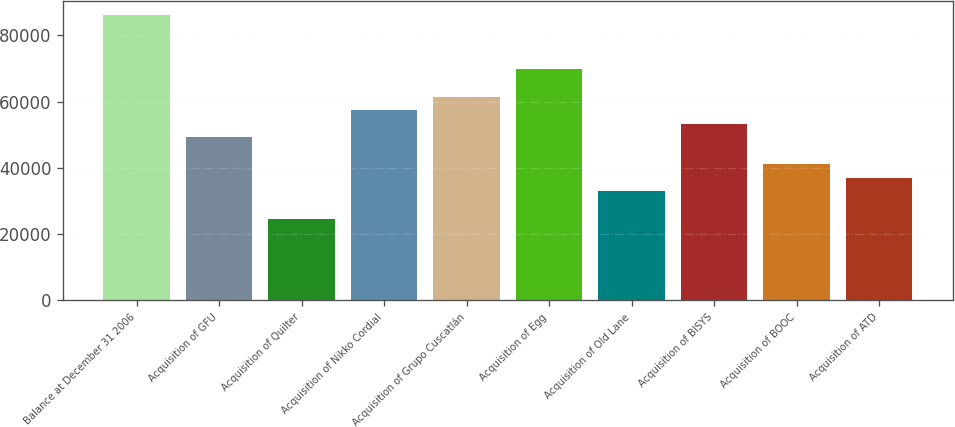Convert chart. <chart><loc_0><loc_0><loc_500><loc_500><bar_chart><fcel>Balance at December 31 2006<fcel>Acquisition of GFU<fcel>Acquisition of Quilter<fcel>Acquisition of Nikko Cordial<fcel>Acquisition of Grupo Cuscatlán<fcel>Acquisition of Egg<fcel>Acquisition of Old Lane<fcel>Acquisition of BISYS<fcel>Acquisition of BOOC<fcel>Acquisition of ATD<nl><fcel>86117.8<fcel>49246.6<fcel>24665.8<fcel>57440.2<fcel>61537<fcel>69730.6<fcel>32859.4<fcel>53343.4<fcel>41053<fcel>36956.2<nl></chart> 